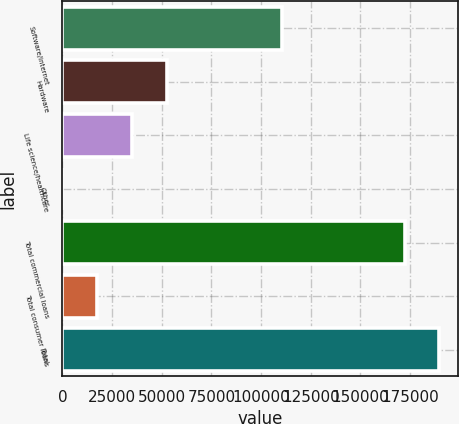Convert chart. <chart><loc_0><loc_0><loc_500><loc_500><bar_chart><fcel>Software/internet<fcel>Hardware<fcel>Life science/healthcare<fcel>Other<fcel>Total commercial loans<fcel>Total consumer loans<fcel>Total<nl><fcel>110654<fcel>52480.7<fcel>34997.8<fcel>32<fcel>172258<fcel>17514.9<fcel>189741<nl></chart> 